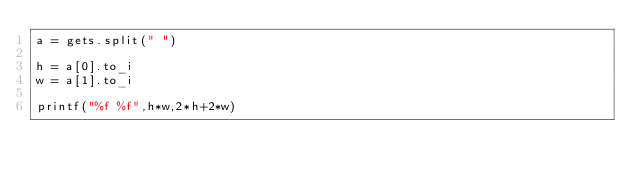<code> <loc_0><loc_0><loc_500><loc_500><_Ruby_>a = gets.split(" ")
 
h = a[0].to_i
w = a[1].to_i
 
printf("%f %f",h*w,2*h+2*w)</code> 